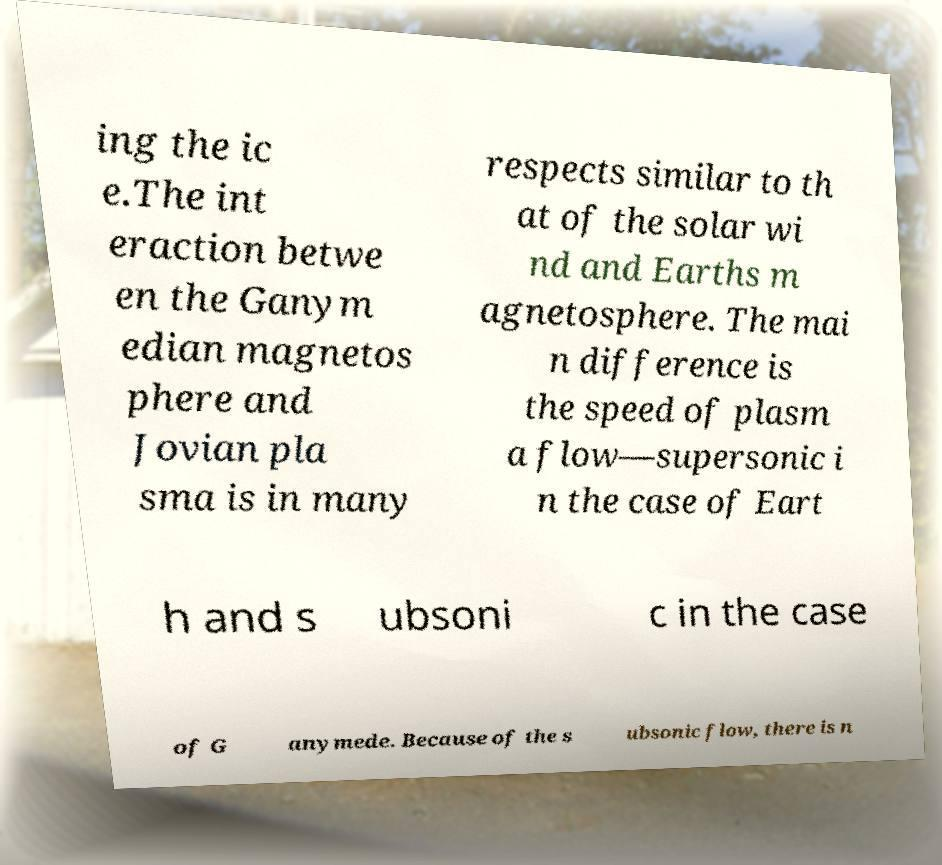Please identify and transcribe the text found in this image. ing the ic e.The int eraction betwe en the Ganym edian magnetos phere and Jovian pla sma is in many respects similar to th at of the solar wi nd and Earths m agnetosphere. The mai n difference is the speed of plasm a flow—supersonic i n the case of Eart h and s ubsoni c in the case of G anymede. Because of the s ubsonic flow, there is n 